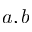<formula> <loc_0><loc_0><loc_500><loc_500>a , b</formula> 